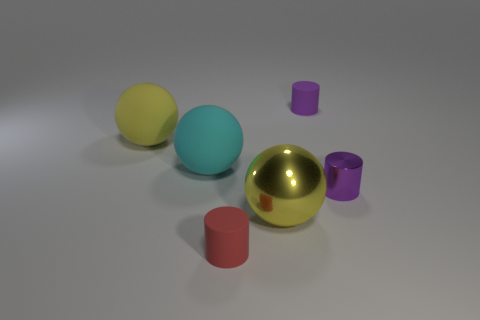Subtract all matte balls. How many balls are left? 1 Add 1 small things. How many objects exist? 7 Subtract all red cylinders. How many cylinders are left? 2 Subtract 3 cylinders. How many cylinders are left? 0 Subtract all gray cylinders. Subtract all red cubes. How many cylinders are left? 3 Subtract all green spheres. How many red cylinders are left? 1 Subtract all large yellow metallic spheres. Subtract all big red metallic things. How many objects are left? 5 Add 5 purple cylinders. How many purple cylinders are left? 7 Add 5 small cyan rubber balls. How many small cyan rubber balls exist? 5 Subtract 0 green blocks. How many objects are left? 6 